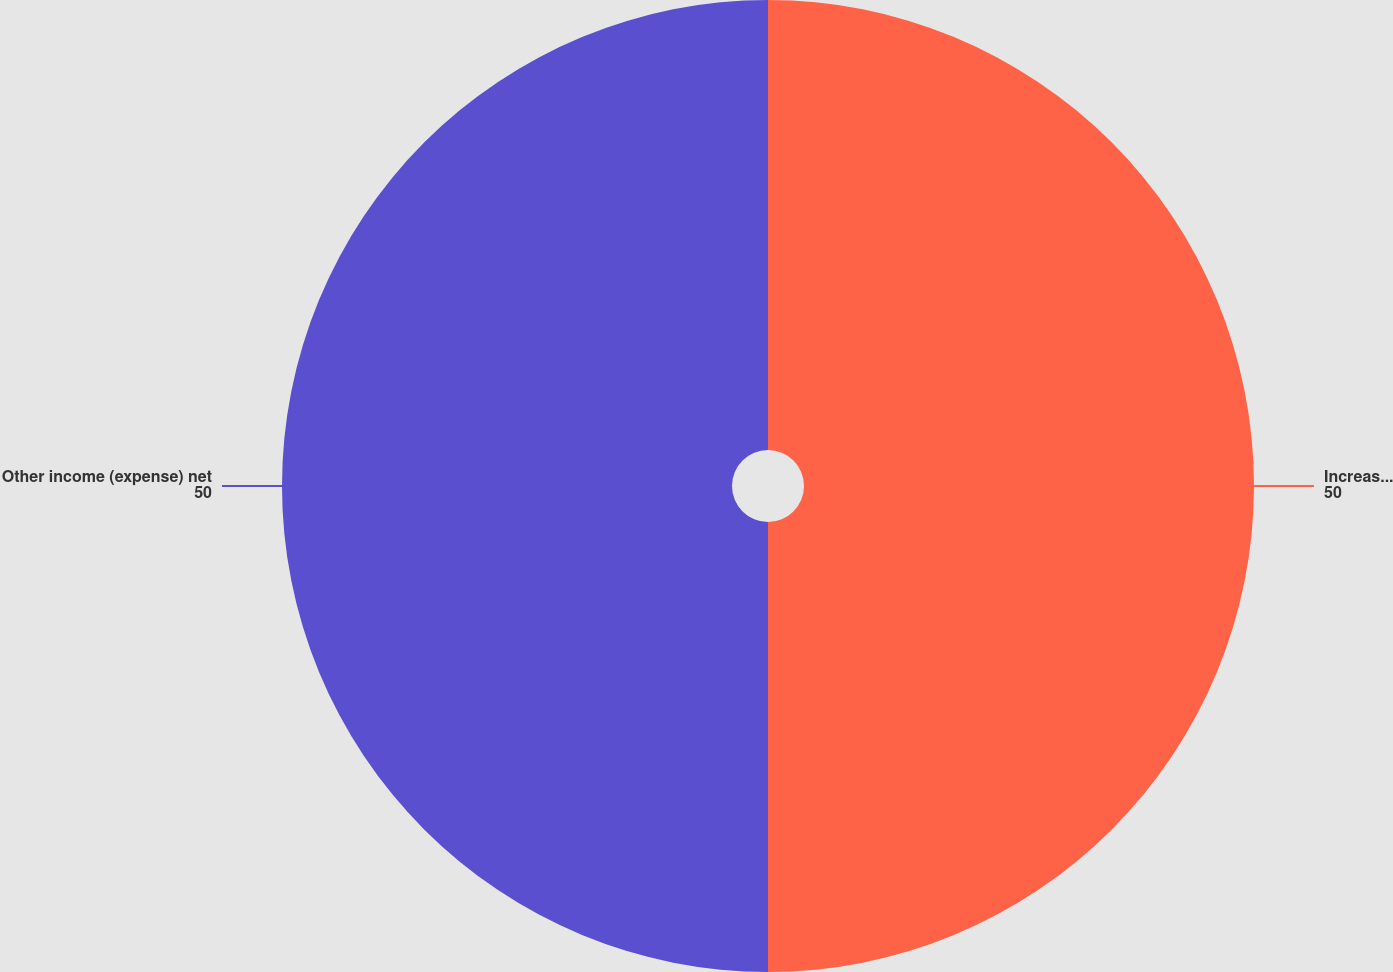<chart> <loc_0><loc_0><loc_500><loc_500><pie_chart><fcel>Increase (reduction) to cost<fcel>Other income (expense) net<nl><fcel>50.0%<fcel>50.0%<nl></chart> 